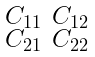<formula> <loc_0><loc_0><loc_500><loc_500>\begin{smallmatrix} C _ { 1 1 } & C _ { 1 2 } \\ C _ { 2 1 } & C _ { 2 2 } \end{smallmatrix}</formula> 